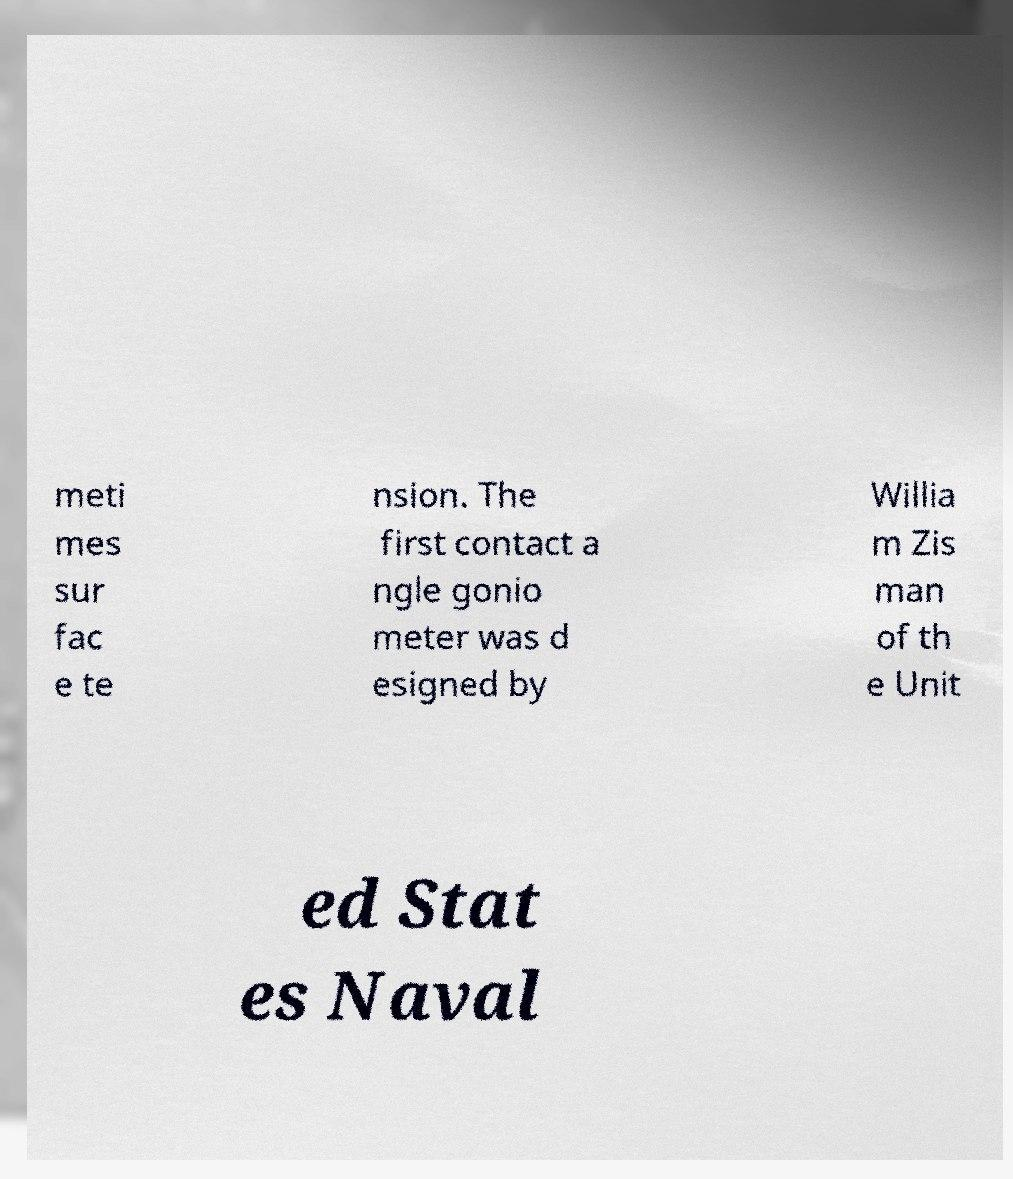I need the written content from this picture converted into text. Can you do that? meti mes sur fac e te nsion. The first contact a ngle gonio meter was d esigned by Willia m Zis man of th e Unit ed Stat es Naval 